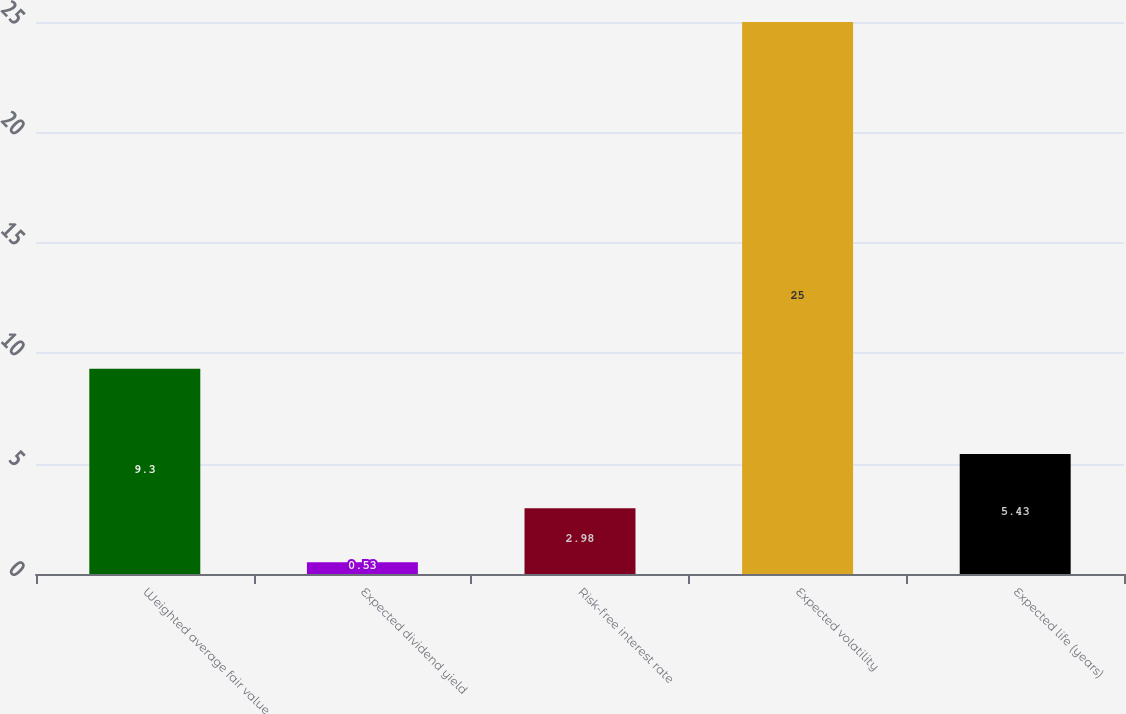Convert chart to OTSL. <chart><loc_0><loc_0><loc_500><loc_500><bar_chart><fcel>Weighted average fair value<fcel>Expected dividend yield<fcel>Risk-free interest rate<fcel>Expected volatility<fcel>Expected life (years)<nl><fcel>9.3<fcel>0.53<fcel>2.98<fcel>25<fcel>5.43<nl></chart> 